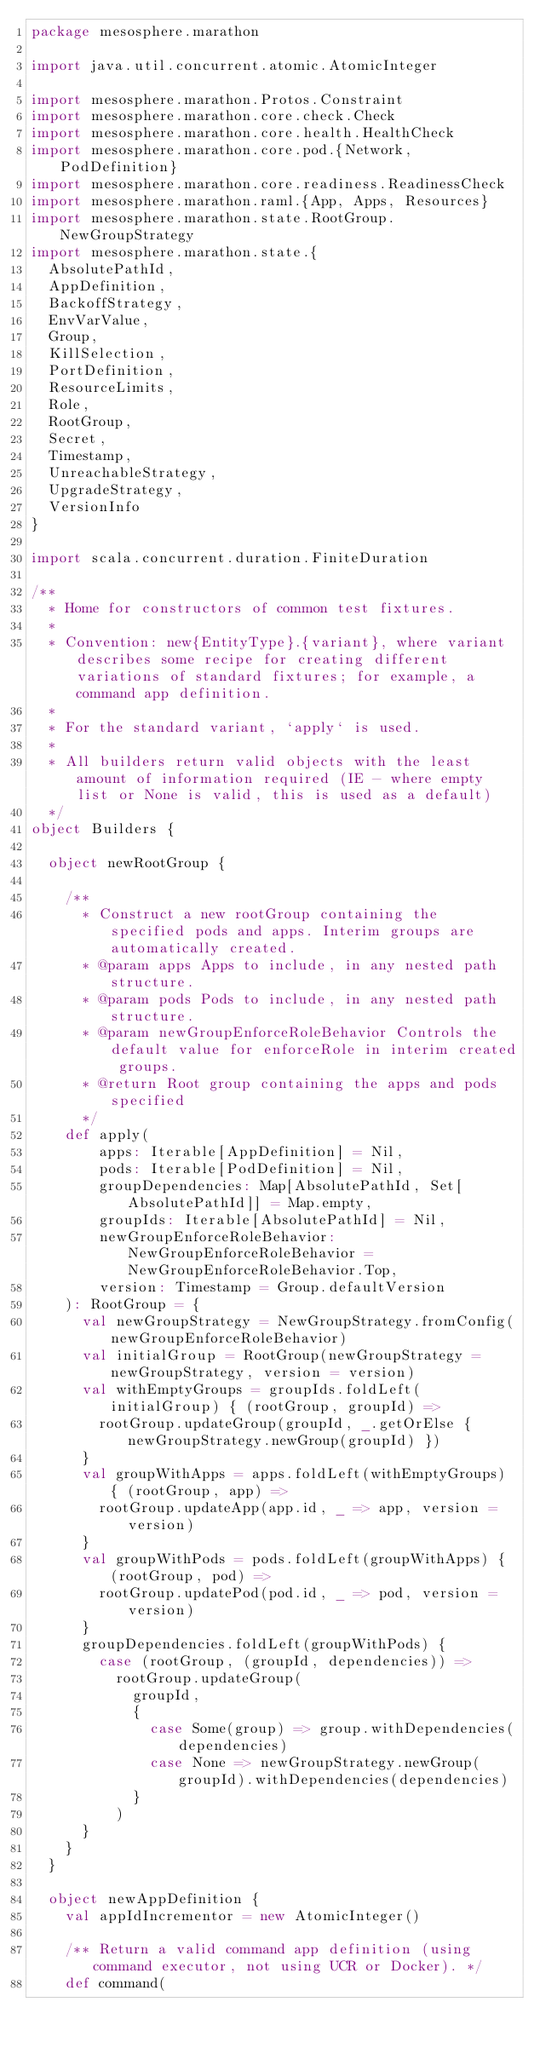Convert code to text. <code><loc_0><loc_0><loc_500><loc_500><_Scala_>package mesosphere.marathon

import java.util.concurrent.atomic.AtomicInteger

import mesosphere.marathon.Protos.Constraint
import mesosphere.marathon.core.check.Check
import mesosphere.marathon.core.health.HealthCheck
import mesosphere.marathon.core.pod.{Network, PodDefinition}
import mesosphere.marathon.core.readiness.ReadinessCheck
import mesosphere.marathon.raml.{App, Apps, Resources}
import mesosphere.marathon.state.RootGroup.NewGroupStrategy
import mesosphere.marathon.state.{
  AbsolutePathId,
  AppDefinition,
  BackoffStrategy,
  EnvVarValue,
  Group,
  KillSelection,
  PortDefinition,
  ResourceLimits,
  Role,
  RootGroup,
  Secret,
  Timestamp,
  UnreachableStrategy,
  UpgradeStrategy,
  VersionInfo
}

import scala.concurrent.duration.FiniteDuration

/**
  * Home for constructors of common test fixtures.
  *
  * Convention: new{EntityType}.{variant}, where variant describes some recipe for creating different variations of standard fixtures; for example, a command app definition.
  *
  * For the standard variant, `apply` is used.
  *
  * All builders return valid objects with the least amount of information required (IE - where empty list or None is valid, this is used as a default)
  */
object Builders {

  object newRootGroup {

    /**
      * Construct a new rootGroup containing the specified pods and apps. Interim groups are automatically created.
      * @param apps Apps to include, in any nested path structure.
      * @param pods Pods to include, in any nested path structure.
      * @param newGroupEnforceRoleBehavior Controls the default value for enforceRole in interim created groups.
      * @return Root group containing the apps and pods specified
      */
    def apply(
        apps: Iterable[AppDefinition] = Nil,
        pods: Iterable[PodDefinition] = Nil,
        groupDependencies: Map[AbsolutePathId, Set[AbsolutePathId]] = Map.empty,
        groupIds: Iterable[AbsolutePathId] = Nil,
        newGroupEnforceRoleBehavior: NewGroupEnforceRoleBehavior = NewGroupEnforceRoleBehavior.Top,
        version: Timestamp = Group.defaultVersion
    ): RootGroup = {
      val newGroupStrategy = NewGroupStrategy.fromConfig(newGroupEnforceRoleBehavior)
      val initialGroup = RootGroup(newGroupStrategy = newGroupStrategy, version = version)
      val withEmptyGroups = groupIds.foldLeft(initialGroup) { (rootGroup, groupId) =>
        rootGroup.updateGroup(groupId, _.getOrElse { newGroupStrategy.newGroup(groupId) })
      }
      val groupWithApps = apps.foldLeft(withEmptyGroups) { (rootGroup, app) =>
        rootGroup.updateApp(app.id, _ => app, version = version)
      }
      val groupWithPods = pods.foldLeft(groupWithApps) { (rootGroup, pod) =>
        rootGroup.updatePod(pod.id, _ => pod, version = version)
      }
      groupDependencies.foldLeft(groupWithPods) {
        case (rootGroup, (groupId, dependencies)) =>
          rootGroup.updateGroup(
            groupId,
            {
              case Some(group) => group.withDependencies(dependencies)
              case None => newGroupStrategy.newGroup(groupId).withDependencies(dependencies)
            }
          )
      }
    }
  }

  object newAppDefinition {
    val appIdIncrementor = new AtomicInteger()

    /** Return a valid command app definition (using command executor, not using UCR or Docker). */
    def command(</code> 